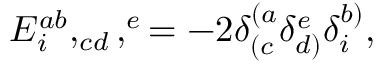Convert formula to latex. <formula><loc_0><loc_0><loc_500><loc_500>E _ { i } ^ { a b } , _ { c d } , ^ { e } = - 2 \delta _ { ( c } ^ { ( a } \delta _ { d ) } ^ { e } \delta _ { i } ^ { b ) } ,</formula> 